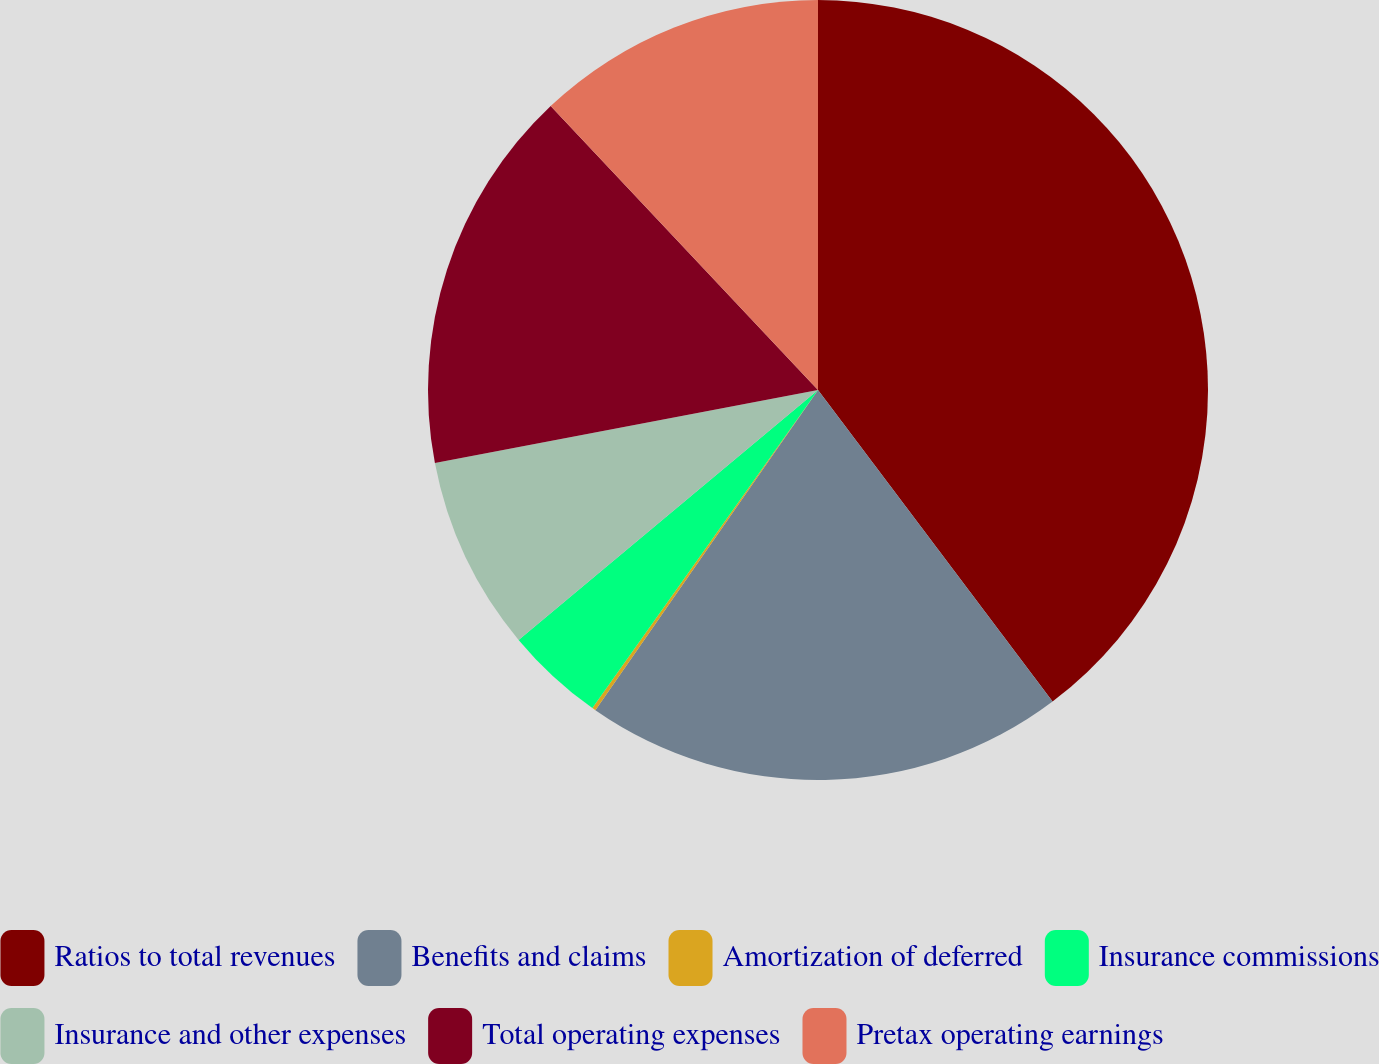Convert chart to OTSL. <chart><loc_0><loc_0><loc_500><loc_500><pie_chart><fcel>Ratios to total revenues<fcel>Benefits and claims<fcel>Amortization of deferred<fcel>Insurance commissions<fcel>Insurance and other expenses<fcel>Total operating expenses<fcel>Pretax operating earnings<nl><fcel>39.73%<fcel>19.94%<fcel>0.15%<fcel>4.11%<fcel>8.07%<fcel>15.98%<fcel>12.02%<nl></chart> 